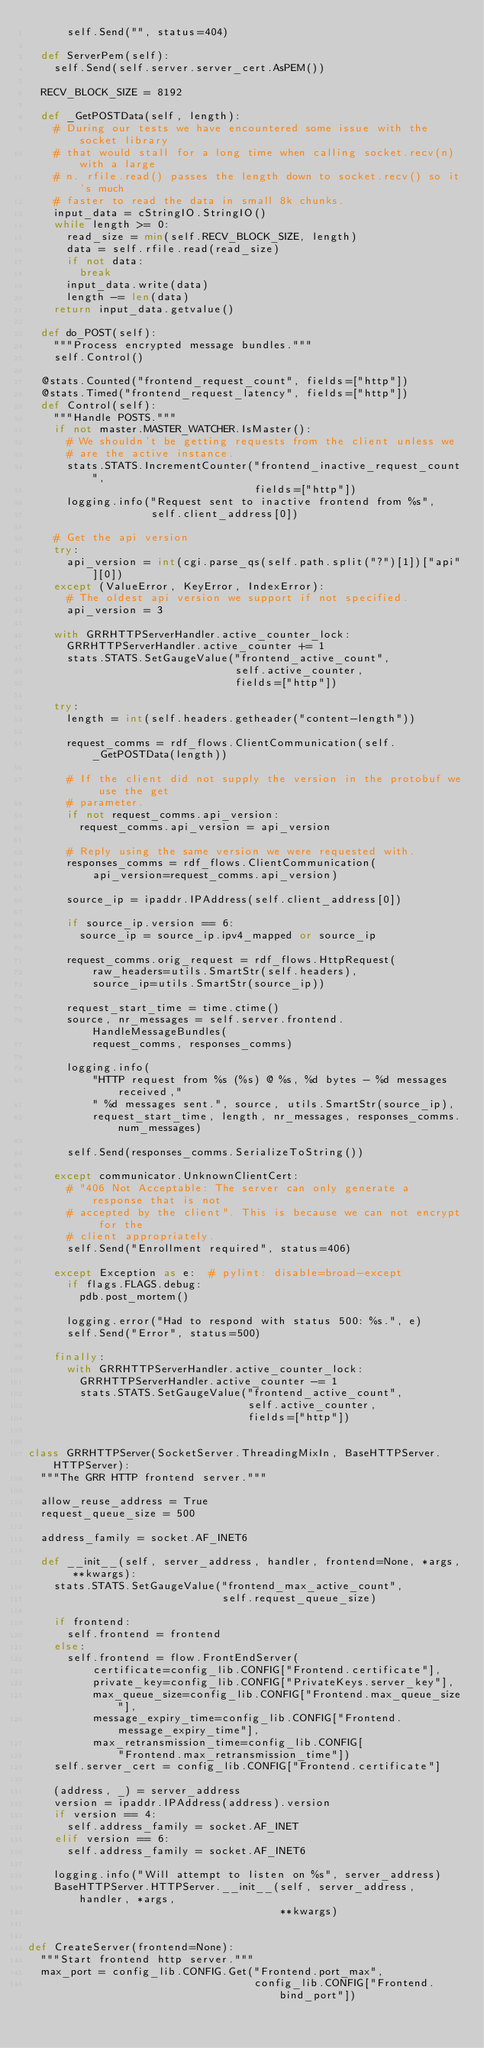<code> <loc_0><loc_0><loc_500><loc_500><_Python_>      self.Send("", status=404)

  def ServerPem(self):
    self.Send(self.server.server_cert.AsPEM())

  RECV_BLOCK_SIZE = 8192

  def _GetPOSTData(self, length):
    # During our tests we have encountered some issue with the socket library
    # that would stall for a long time when calling socket.recv(n) with a large
    # n. rfile.read() passes the length down to socket.recv() so it's much
    # faster to read the data in small 8k chunks.
    input_data = cStringIO.StringIO()
    while length >= 0:
      read_size = min(self.RECV_BLOCK_SIZE, length)
      data = self.rfile.read(read_size)
      if not data:
        break
      input_data.write(data)
      length -= len(data)
    return input_data.getvalue()

  def do_POST(self):
    """Process encrypted message bundles."""
    self.Control()

  @stats.Counted("frontend_request_count", fields=["http"])
  @stats.Timed("frontend_request_latency", fields=["http"])
  def Control(self):
    """Handle POSTS."""
    if not master.MASTER_WATCHER.IsMaster():
      # We shouldn't be getting requests from the client unless we
      # are the active instance.
      stats.STATS.IncrementCounter("frontend_inactive_request_count",
                                   fields=["http"])
      logging.info("Request sent to inactive frontend from %s",
                   self.client_address[0])

    # Get the api version
    try:
      api_version = int(cgi.parse_qs(self.path.split("?")[1])["api"][0])
    except (ValueError, KeyError, IndexError):
      # The oldest api version we support if not specified.
      api_version = 3

    with GRRHTTPServerHandler.active_counter_lock:
      GRRHTTPServerHandler.active_counter += 1
      stats.STATS.SetGaugeValue("frontend_active_count",
                                self.active_counter,
                                fields=["http"])

    try:
      length = int(self.headers.getheader("content-length"))

      request_comms = rdf_flows.ClientCommunication(self._GetPOSTData(length))

      # If the client did not supply the version in the protobuf we use the get
      # parameter.
      if not request_comms.api_version:
        request_comms.api_version = api_version

      # Reply using the same version we were requested with.
      responses_comms = rdf_flows.ClientCommunication(
          api_version=request_comms.api_version)

      source_ip = ipaddr.IPAddress(self.client_address[0])

      if source_ip.version == 6:
        source_ip = source_ip.ipv4_mapped or source_ip

      request_comms.orig_request = rdf_flows.HttpRequest(
          raw_headers=utils.SmartStr(self.headers),
          source_ip=utils.SmartStr(source_ip))

      request_start_time = time.ctime()
      source, nr_messages = self.server.frontend.HandleMessageBundles(
          request_comms, responses_comms)

      logging.info(
          "HTTP request from %s (%s) @ %s, %d bytes - %d messages received,"
          " %d messages sent.", source, utils.SmartStr(source_ip),
          request_start_time, length, nr_messages, responses_comms.num_messages)

      self.Send(responses_comms.SerializeToString())

    except communicator.UnknownClientCert:
      # "406 Not Acceptable: The server can only generate a response that is not
      # accepted by the client". This is because we can not encrypt for the
      # client appropriately.
      self.Send("Enrollment required", status=406)

    except Exception as e:  # pylint: disable=broad-except
      if flags.FLAGS.debug:
        pdb.post_mortem()

      logging.error("Had to respond with status 500: %s.", e)
      self.Send("Error", status=500)

    finally:
      with GRRHTTPServerHandler.active_counter_lock:
        GRRHTTPServerHandler.active_counter -= 1
        stats.STATS.SetGaugeValue("frontend_active_count",
                                  self.active_counter,
                                  fields=["http"])


class GRRHTTPServer(SocketServer.ThreadingMixIn, BaseHTTPServer.HTTPServer):
  """The GRR HTTP frontend server."""

  allow_reuse_address = True
  request_queue_size = 500

  address_family = socket.AF_INET6

  def __init__(self, server_address, handler, frontend=None, *args, **kwargs):
    stats.STATS.SetGaugeValue("frontend_max_active_count",
                              self.request_queue_size)

    if frontend:
      self.frontend = frontend
    else:
      self.frontend = flow.FrontEndServer(
          certificate=config_lib.CONFIG["Frontend.certificate"],
          private_key=config_lib.CONFIG["PrivateKeys.server_key"],
          max_queue_size=config_lib.CONFIG["Frontend.max_queue_size"],
          message_expiry_time=config_lib.CONFIG["Frontend.message_expiry_time"],
          max_retransmission_time=config_lib.CONFIG[
              "Frontend.max_retransmission_time"])
    self.server_cert = config_lib.CONFIG["Frontend.certificate"]

    (address, _) = server_address
    version = ipaddr.IPAddress(address).version
    if version == 4:
      self.address_family = socket.AF_INET
    elif version == 6:
      self.address_family = socket.AF_INET6

    logging.info("Will attempt to listen on %s", server_address)
    BaseHTTPServer.HTTPServer.__init__(self, server_address, handler, *args,
                                       **kwargs)


def CreateServer(frontend=None):
  """Start frontend http server."""
  max_port = config_lib.CONFIG.Get("Frontend.port_max",
                                   config_lib.CONFIG["Frontend.bind_port"])
</code> 